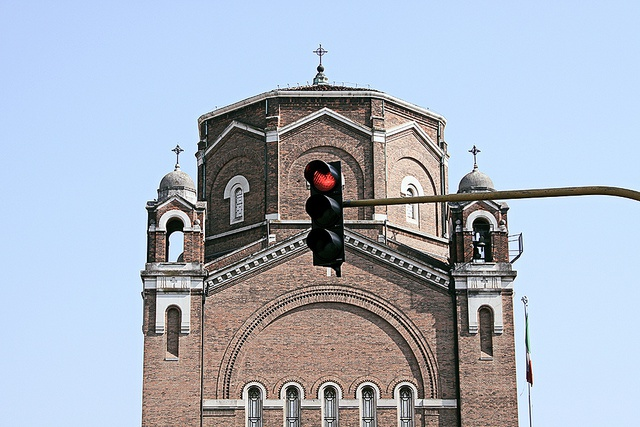Describe the objects in this image and their specific colors. I can see a traffic light in lavender, black, gray, maroon, and darkgray tones in this image. 